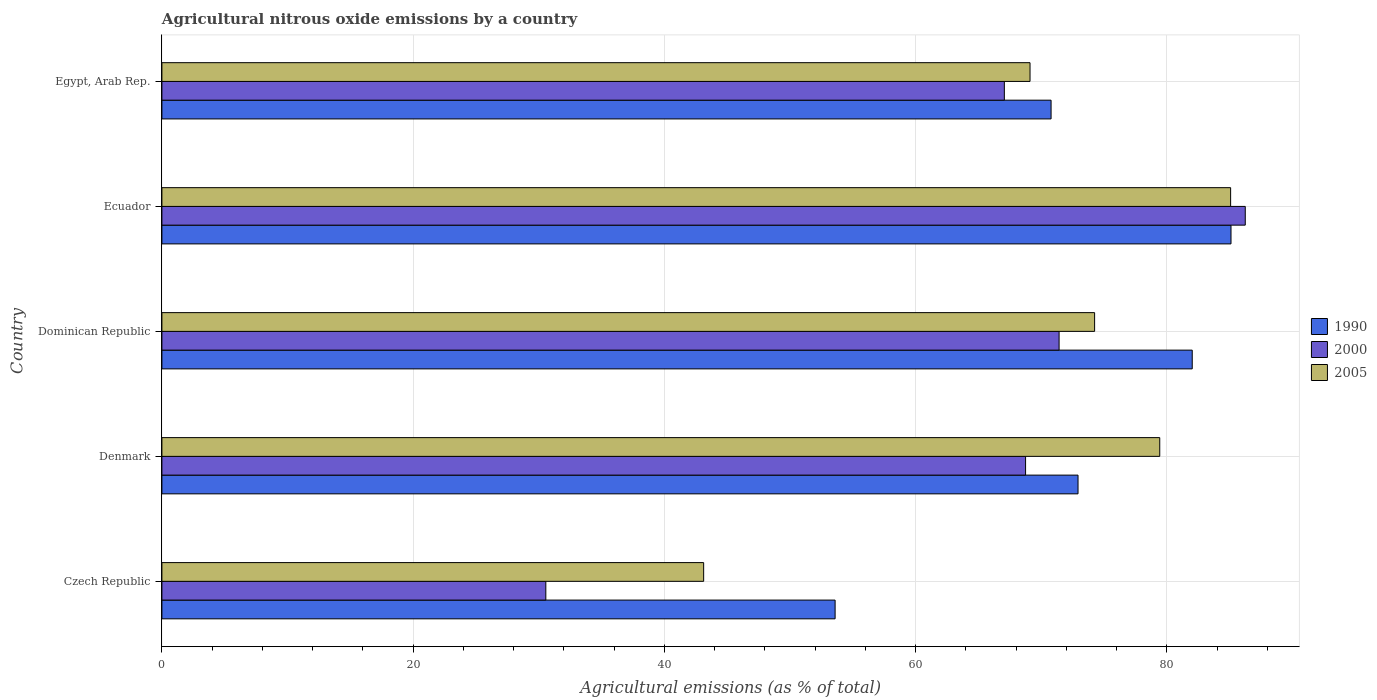How many groups of bars are there?
Keep it short and to the point. 5. Are the number of bars per tick equal to the number of legend labels?
Your answer should be compact. Yes. Are the number of bars on each tick of the Y-axis equal?
Offer a very short reply. Yes. What is the label of the 2nd group of bars from the top?
Provide a short and direct response. Ecuador. In how many cases, is the number of bars for a given country not equal to the number of legend labels?
Keep it short and to the point. 0. What is the amount of agricultural nitrous oxide emitted in 2005 in Czech Republic?
Your answer should be very brief. 43.13. Across all countries, what is the maximum amount of agricultural nitrous oxide emitted in 2005?
Provide a short and direct response. 85.08. Across all countries, what is the minimum amount of agricultural nitrous oxide emitted in 2005?
Offer a very short reply. 43.13. In which country was the amount of agricultural nitrous oxide emitted in 2005 maximum?
Provide a short and direct response. Ecuador. In which country was the amount of agricultural nitrous oxide emitted in 1990 minimum?
Keep it short and to the point. Czech Republic. What is the total amount of agricultural nitrous oxide emitted in 2005 in the graph?
Give a very brief answer. 351.02. What is the difference between the amount of agricultural nitrous oxide emitted in 1990 in Dominican Republic and that in Egypt, Arab Rep.?
Ensure brevity in your answer.  11.24. What is the difference between the amount of agricultural nitrous oxide emitted in 2000 in Czech Republic and the amount of agricultural nitrous oxide emitted in 2005 in Egypt, Arab Rep.?
Provide a succinct answer. -38.55. What is the average amount of agricultural nitrous oxide emitted in 2005 per country?
Provide a succinct answer. 70.2. What is the difference between the amount of agricultural nitrous oxide emitted in 1990 and amount of agricultural nitrous oxide emitted in 2000 in Czech Republic?
Your response must be concise. 23.03. What is the ratio of the amount of agricultural nitrous oxide emitted in 1990 in Denmark to that in Egypt, Arab Rep.?
Your answer should be very brief. 1.03. What is the difference between the highest and the second highest amount of agricultural nitrous oxide emitted in 2000?
Your answer should be very brief. 14.82. What is the difference between the highest and the lowest amount of agricultural nitrous oxide emitted in 1990?
Make the answer very short. 31.52. In how many countries, is the amount of agricultural nitrous oxide emitted in 1990 greater than the average amount of agricultural nitrous oxide emitted in 1990 taken over all countries?
Provide a succinct answer. 3. Is the sum of the amount of agricultural nitrous oxide emitted in 1990 in Czech Republic and Ecuador greater than the maximum amount of agricultural nitrous oxide emitted in 2005 across all countries?
Keep it short and to the point. Yes. What does the 2nd bar from the bottom in Denmark represents?
Your answer should be very brief. 2000. What is the difference between two consecutive major ticks on the X-axis?
Keep it short and to the point. 20. Does the graph contain grids?
Offer a very short reply. Yes. Where does the legend appear in the graph?
Offer a terse response. Center right. What is the title of the graph?
Your response must be concise. Agricultural nitrous oxide emissions by a country. What is the label or title of the X-axis?
Offer a terse response. Agricultural emissions (as % of total). What is the Agricultural emissions (as % of total) in 1990 in Czech Republic?
Make the answer very short. 53.6. What is the Agricultural emissions (as % of total) of 2000 in Czech Republic?
Provide a short and direct response. 30.56. What is the Agricultural emissions (as % of total) of 2005 in Czech Republic?
Your answer should be compact. 43.13. What is the Agricultural emissions (as % of total) of 1990 in Denmark?
Offer a terse response. 72.93. What is the Agricultural emissions (as % of total) of 2000 in Denmark?
Make the answer very short. 68.76. What is the Agricultural emissions (as % of total) of 2005 in Denmark?
Offer a very short reply. 79.44. What is the Agricultural emissions (as % of total) in 1990 in Dominican Republic?
Offer a terse response. 82.03. What is the Agricultural emissions (as % of total) of 2000 in Dominican Republic?
Offer a terse response. 71.43. What is the Agricultural emissions (as % of total) in 2005 in Dominican Republic?
Give a very brief answer. 74.25. What is the Agricultural emissions (as % of total) of 1990 in Ecuador?
Offer a very short reply. 85.11. What is the Agricultural emissions (as % of total) of 2000 in Ecuador?
Keep it short and to the point. 86.25. What is the Agricultural emissions (as % of total) in 2005 in Ecuador?
Make the answer very short. 85.08. What is the Agricultural emissions (as % of total) in 1990 in Egypt, Arab Rep.?
Your answer should be compact. 70.79. What is the Agricultural emissions (as % of total) in 2000 in Egypt, Arab Rep.?
Offer a very short reply. 67.07. What is the Agricultural emissions (as % of total) in 2005 in Egypt, Arab Rep.?
Give a very brief answer. 69.11. Across all countries, what is the maximum Agricultural emissions (as % of total) in 1990?
Ensure brevity in your answer.  85.11. Across all countries, what is the maximum Agricultural emissions (as % of total) in 2000?
Provide a short and direct response. 86.25. Across all countries, what is the maximum Agricultural emissions (as % of total) in 2005?
Offer a terse response. 85.08. Across all countries, what is the minimum Agricultural emissions (as % of total) of 1990?
Give a very brief answer. 53.6. Across all countries, what is the minimum Agricultural emissions (as % of total) in 2000?
Give a very brief answer. 30.56. Across all countries, what is the minimum Agricultural emissions (as % of total) in 2005?
Your answer should be very brief. 43.13. What is the total Agricultural emissions (as % of total) of 1990 in the graph?
Your answer should be compact. 364.46. What is the total Agricultural emissions (as % of total) in 2000 in the graph?
Your answer should be compact. 324.07. What is the total Agricultural emissions (as % of total) of 2005 in the graph?
Your response must be concise. 351.02. What is the difference between the Agricultural emissions (as % of total) of 1990 in Czech Republic and that in Denmark?
Your response must be concise. -19.34. What is the difference between the Agricultural emissions (as % of total) in 2000 in Czech Republic and that in Denmark?
Offer a very short reply. -38.19. What is the difference between the Agricultural emissions (as % of total) of 2005 in Czech Republic and that in Denmark?
Offer a very short reply. -36.31. What is the difference between the Agricultural emissions (as % of total) in 1990 in Czech Republic and that in Dominican Republic?
Your answer should be compact. -28.43. What is the difference between the Agricultural emissions (as % of total) of 2000 in Czech Republic and that in Dominican Republic?
Offer a terse response. -40.86. What is the difference between the Agricultural emissions (as % of total) of 2005 in Czech Republic and that in Dominican Republic?
Keep it short and to the point. -31.12. What is the difference between the Agricultural emissions (as % of total) of 1990 in Czech Republic and that in Ecuador?
Provide a short and direct response. -31.52. What is the difference between the Agricultural emissions (as % of total) of 2000 in Czech Republic and that in Ecuador?
Ensure brevity in your answer.  -55.68. What is the difference between the Agricultural emissions (as % of total) of 2005 in Czech Republic and that in Ecuador?
Provide a short and direct response. -41.95. What is the difference between the Agricultural emissions (as % of total) in 1990 in Czech Republic and that in Egypt, Arab Rep.?
Give a very brief answer. -17.19. What is the difference between the Agricultural emissions (as % of total) of 2000 in Czech Republic and that in Egypt, Arab Rep.?
Your answer should be compact. -36.5. What is the difference between the Agricultural emissions (as % of total) of 2005 in Czech Republic and that in Egypt, Arab Rep.?
Keep it short and to the point. -25.98. What is the difference between the Agricultural emissions (as % of total) in 1990 in Denmark and that in Dominican Republic?
Make the answer very short. -9.09. What is the difference between the Agricultural emissions (as % of total) in 2000 in Denmark and that in Dominican Republic?
Your response must be concise. -2.67. What is the difference between the Agricultural emissions (as % of total) in 2005 in Denmark and that in Dominican Republic?
Your response must be concise. 5.19. What is the difference between the Agricultural emissions (as % of total) of 1990 in Denmark and that in Ecuador?
Provide a succinct answer. -12.18. What is the difference between the Agricultural emissions (as % of total) of 2000 in Denmark and that in Ecuador?
Give a very brief answer. -17.49. What is the difference between the Agricultural emissions (as % of total) of 2005 in Denmark and that in Ecuador?
Your response must be concise. -5.64. What is the difference between the Agricultural emissions (as % of total) of 1990 in Denmark and that in Egypt, Arab Rep.?
Your response must be concise. 2.15. What is the difference between the Agricultural emissions (as % of total) in 2000 in Denmark and that in Egypt, Arab Rep.?
Provide a short and direct response. 1.69. What is the difference between the Agricultural emissions (as % of total) in 2005 in Denmark and that in Egypt, Arab Rep.?
Your response must be concise. 10.33. What is the difference between the Agricultural emissions (as % of total) of 1990 in Dominican Republic and that in Ecuador?
Your response must be concise. -3.09. What is the difference between the Agricultural emissions (as % of total) in 2000 in Dominican Republic and that in Ecuador?
Keep it short and to the point. -14.82. What is the difference between the Agricultural emissions (as % of total) of 2005 in Dominican Republic and that in Ecuador?
Provide a short and direct response. -10.83. What is the difference between the Agricultural emissions (as % of total) of 1990 in Dominican Republic and that in Egypt, Arab Rep.?
Your answer should be compact. 11.24. What is the difference between the Agricultural emissions (as % of total) in 2000 in Dominican Republic and that in Egypt, Arab Rep.?
Ensure brevity in your answer.  4.36. What is the difference between the Agricultural emissions (as % of total) of 2005 in Dominican Republic and that in Egypt, Arab Rep.?
Your answer should be compact. 5.14. What is the difference between the Agricultural emissions (as % of total) of 1990 in Ecuador and that in Egypt, Arab Rep.?
Provide a succinct answer. 14.32. What is the difference between the Agricultural emissions (as % of total) of 2000 in Ecuador and that in Egypt, Arab Rep.?
Provide a short and direct response. 19.18. What is the difference between the Agricultural emissions (as % of total) of 2005 in Ecuador and that in Egypt, Arab Rep.?
Provide a succinct answer. 15.97. What is the difference between the Agricultural emissions (as % of total) in 1990 in Czech Republic and the Agricultural emissions (as % of total) in 2000 in Denmark?
Offer a terse response. -15.16. What is the difference between the Agricultural emissions (as % of total) in 1990 in Czech Republic and the Agricultural emissions (as % of total) in 2005 in Denmark?
Your answer should be compact. -25.85. What is the difference between the Agricultural emissions (as % of total) of 2000 in Czech Republic and the Agricultural emissions (as % of total) of 2005 in Denmark?
Give a very brief answer. -48.88. What is the difference between the Agricultural emissions (as % of total) in 1990 in Czech Republic and the Agricultural emissions (as % of total) in 2000 in Dominican Republic?
Your answer should be compact. -17.83. What is the difference between the Agricultural emissions (as % of total) in 1990 in Czech Republic and the Agricultural emissions (as % of total) in 2005 in Dominican Republic?
Provide a short and direct response. -20.66. What is the difference between the Agricultural emissions (as % of total) in 2000 in Czech Republic and the Agricultural emissions (as % of total) in 2005 in Dominican Republic?
Provide a succinct answer. -43.69. What is the difference between the Agricultural emissions (as % of total) of 1990 in Czech Republic and the Agricultural emissions (as % of total) of 2000 in Ecuador?
Provide a short and direct response. -32.65. What is the difference between the Agricultural emissions (as % of total) of 1990 in Czech Republic and the Agricultural emissions (as % of total) of 2005 in Ecuador?
Your response must be concise. -31.49. What is the difference between the Agricultural emissions (as % of total) of 2000 in Czech Republic and the Agricultural emissions (as % of total) of 2005 in Ecuador?
Provide a succinct answer. -54.52. What is the difference between the Agricultural emissions (as % of total) of 1990 in Czech Republic and the Agricultural emissions (as % of total) of 2000 in Egypt, Arab Rep.?
Your answer should be compact. -13.47. What is the difference between the Agricultural emissions (as % of total) in 1990 in Czech Republic and the Agricultural emissions (as % of total) in 2005 in Egypt, Arab Rep.?
Keep it short and to the point. -15.52. What is the difference between the Agricultural emissions (as % of total) in 2000 in Czech Republic and the Agricultural emissions (as % of total) in 2005 in Egypt, Arab Rep.?
Keep it short and to the point. -38.55. What is the difference between the Agricultural emissions (as % of total) of 1990 in Denmark and the Agricultural emissions (as % of total) of 2000 in Dominican Republic?
Provide a short and direct response. 1.51. What is the difference between the Agricultural emissions (as % of total) in 1990 in Denmark and the Agricultural emissions (as % of total) in 2005 in Dominican Republic?
Provide a short and direct response. -1.32. What is the difference between the Agricultural emissions (as % of total) of 2000 in Denmark and the Agricultural emissions (as % of total) of 2005 in Dominican Republic?
Provide a succinct answer. -5.5. What is the difference between the Agricultural emissions (as % of total) of 1990 in Denmark and the Agricultural emissions (as % of total) of 2000 in Ecuador?
Offer a terse response. -13.31. What is the difference between the Agricultural emissions (as % of total) in 1990 in Denmark and the Agricultural emissions (as % of total) in 2005 in Ecuador?
Provide a short and direct response. -12.15. What is the difference between the Agricultural emissions (as % of total) in 2000 in Denmark and the Agricultural emissions (as % of total) in 2005 in Ecuador?
Give a very brief answer. -16.32. What is the difference between the Agricultural emissions (as % of total) in 1990 in Denmark and the Agricultural emissions (as % of total) in 2000 in Egypt, Arab Rep.?
Provide a short and direct response. 5.87. What is the difference between the Agricultural emissions (as % of total) in 1990 in Denmark and the Agricultural emissions (as % of total) in 2005 in Egypt, Arab Rep.?
Keep it short and to the point. 3.82. What is the difference between the Agricultural emissions (as % of total) of 2000 in Denmark and the Agricultural emissions (as % of total) of 2005 in Egypt, Arab Rep.?
Offer a terse response. -0.35. What is the difference between the Agricultural emissions (as % of total) in 1990 in Dominican Republic and the Agricultural emissions (as % of total) in 2000 in Ecuador?
Your answer should be very brief. -4.22. What is the difference between the Agricultural emissions (as % of total) in 1990 in Dominican Republic and the Agricultural emissions (as % of total) in 2005 in Ecuador?
Ensure brevity in your answer.  -3.06. What is the difference between the Agricultural emissions (as % of total) of 2000 in Dominican Republic and the Agricultural emissions (as % of total) of 2005 in Ecuador?
Offer a terse response. -13.66. What is the difference between the Agricultural emissions (as % of total) of 1990 in Dominican Republic and the Agricultural emissions (as % of total) of 2000 in Egypt, Arab Rep.?
Your answer should be compact. 14.96. What is the difference between the Agricultural emissions (as % of total) in 1990 in Dominican Republic and the Agricultural emissions (as % of total) in 2005 in Egypt, Arab Rep.?
Your answer should be compact. 12.91. What is the difference between the Agricultural emissions (as % of total) of 2000 in Dominican Republic and the Agricultural emissions (as % of total) of 2005 in Egypt, Arab Rep.?
Your answer should be compact. 2.31. What is the difference between the Agricultural emissions (as % of total) of 1990 in Ecuador and the Agricultural emissions (as % of total) of 2000 in Egypt, Arab Rep.?
Your answer should be very brief. 18.05. What is the difference between the Agricultural emissions (as % of total) in 1990 in Ecuador and the Agricultural emissions (as % of total) in 2005 in Egypt, Arab Rep.?
Provide a short and direct response. 16. What is the difference between the Agricultural emissions (as % of total) of 2000 in Ecuador and the Agricultural emissions (as % of total) of 2005 in Egypt, Arab Rep.?
Ensure brevity in your answer.  17.13. What is the average Agricultural emissions (as % of total) in 1990 per country?
Offer a terse response. 72.89. What is the average Agricultural emissions (as % of total) in 2000 per country?
Provide a succinct answer. 64.81. What is the average Agricultural emissions (as % of total) in 2005 per country?
Your answer should be compact. 70.2. What is the difference between the Agricultural emissions (as % of total) of 1990 and Agricultural emissions (as % of total) of 2000 in Czech Republic?
Your answer should be compact. 23.03. What is the difference between the Agricultural emissions (as % of total) of 1990 and Agricultural emissions (as % of total) of 2005 in Czech Republic?
Offer a very short reply. 10.47. What is the difference between the Agricultural emissions (as % of total) in 2000 and Agricultural emissions (as % of total) in 2005 in Czech Republic?
Your response must be concise. -12.57. What is the difference between the Agricultural emissions (as % of total) of 1990 and Agricultural emissions (as % of total) of 2000 in Denmark?
Give a very brief answer. 4.18. What is the difference between the Agricultural emissions (as % of total) in 1990 and Agricultural emissions (as % of total) in 2005 in Denmark?
Keep it short and to the point. -6.51. What is the difference between the Agricultural emissions (as % of total) in 2000 and Agricultural emissions (as % of total) in 2005 in Denmark?
Your answer should be very brief. -10.68. What is the difference between the Agricultural emissions (as % of total) in 1990 and Agricultural emissions (as % of total) in 2000 in Dominican Republic?
Offer a terse response. 10.6. What is the difference between the Agricultural emissions (as % of total) in 1990 and Agricultural emissions (as % of total) in 2005 in Dominican Republic?
Provide a succinct answer. 7.77. What is the difference between the Agricultural emissions (as % of total) of 2000 and Agricultural emissions (as % of total) of 2005 in Dominican Republic?
Keep it short and to the point. -2.83. What is the difference between the Agricultural emissions (as % of total) in 1990 and Agricultural emissions (as % of total) in 2000 in Ecuador?
Ensure brevity in your answer.  -1.14. What is the difference between the Agricultural emissions (as % of total) of 1990 and Agricultural emissions (as % of total) of 2005 in Ecuador?
Make the answer very short. 0.03. What is the difference between the Agricultural emissions (as % of total) of 2000 and Agricultural emissions (as % of total) of 2005 in Ecuador?
Offer a terse response. 1.16. What is the difference between the Agricultural emissions (as % of total) in 1990 and Agricultural emissions (as % of total) in 2000 in Egypt, Arab Rep.?
Keep it short and to the point. 3.72. What is the difference between the Agricultural emissions (as % of total) in 1990 and Agricultural emissions (as % of total) in 2005 in Egypt, Arab Rep.?
Keep it short and to the point. 1.68. What is the difference between the Agricultural emissions (as % of total) of 2000 and Agricultural emissions (as % of total) of 2005 in Egypt, Arab Rep.?
Offer a terse response. -2.05. What is the ratio of the Agricultural emissions (as % of total) of 1990 in Czech Republic to that in Denmark?
Your answer should be very brief. 0.73. What is the ratio of the Agricultural emissions (as % of total) of 2000 in Czech Republic to that in Denmark?
Give a very brief answer. 0.44. What is the ratio of the Agricultural emissions (as % of total) in 2005 in Czech Republic to that in Denmark?
Ensure brevity in your answer.  0.54. What is the ratio of the Agricultural emissions (as % of total) in 1990 in Czech Republic to that in Dominican Republic?
Offer a terse response. 0.65. What is the ratio of the Agricultural emissions (as % of total) of 2000 in Czech Republic to that in Dominican Republic?
Your answer should be compact. 0.43. What is the ratio of the Agricultural emissions (as % of total) in 2005 in Czech Republic to that in Dominican Republic?
Your answer should be compact. 0.58. What is the ratio of the Agricultural emissions (as % of total) in 1990 in Czech Republic to that in Ecuador?
Offer a terse response. 0.63. What is the ratio of the Agricultural emissions (as % of total) of 2000 in Czech Republic to that in Ecuador?
Give a very brief answer. 0.35. What is the ratio of the Agricultural emissions (as % of total) of 2005 in Czech Republic to that in Ecuador?
Provide a short and direct response. 0.51. What is the ratio of the Agricultural emissions (as % of total) of 1990 in Czech Republic to that in Egypt, Arab Rep.?
Offer a very short reply. 0.76. What is the ratio of the Agricultural emissions (as % of total) in 2000 in Czech Republic to that in Egypt, Arab Rep.?
Offer a terse response. 0.46. What is the ratio of the Agricultural emissions (as % of total) in 2005 in Czech Republic to that in Egypt, Arab Rep.?
Give a very brief answer. 0.62. What is the ratio of the Agricultural emissions (as % of total) in 1990 in Denmark to that in Dominican Republic?
Provide a succinct answer. 0.89. What is the ratio of the Agricultural emissions (as % of total) in 2000 in Denmark to that in Dominican Republic?
Provide a succinct answer. 0.96. What is the ratio of the Agricultural emissions (as % of total) in 2005 in Denmark to that in Dominican Republic?
Offer a terse response. 1.07. What is the ratio of the Agricultural emissions (as % of total) of 1990 in Denmark to that in Ecuador?
Your answer should be compact. 0.86. What is the ratio of the Agricultural emissions (as % of total) of 2000 in Denmark to that in Ecuador?
Your response must be concise. 0.8. What is the ratio of the Agricultural emissions (as % of total) of 2005 in Denmark to that in Ecuador?
Offer a terse response. 0.93. What is the ratio of the Agricultural emissions (as % of total) of 1990 in Denmark to that in Egypt, Arab Rep.?
Make the answer very short. 1.03. What is the ratio of the Agricultural emissions (as % of total) of 2000 in Denmark to that in Egypt, Arab Rep.?
Your response must be concise. 1.03. What is the ratio of the Agricultural emissions (as % of total) of 2005 in Denmark to that in Egypt, Arab Rep.?
Provide a succinct answer. 1.15. What is the ratio of the Agricultural emissions (as % of total) in 1990 in Dominican Republic to that in Ecuador?
Keep it short and to the point. 0.96. What is the ratio of the Agricultural emissions (as % of total) in 2000 in Dominican Republic to that in Ecuador?
Make the answer very short. 0.83. What is the ratio of the Agricultural emissions (as % of total) of 2005 in Dominican Republic to that in Ecuador?
Your response must be concise. 0.87. What is the ratio of the Agricultural emissions (as % of total) in 1990 in Dominican Republic to that in Egypt, Arab Rep.?
Keep it short and to the point. 1.16. What is the ratio of the Agricultural emissions (as % of total) of 2000 in Dominican Republic to that in Egypt, Arab Rep.?
Offer a very short reply. 1.06. What is the ratio of the Agricultural emissions (as % of total) in 2005 in Dominican Republic to that in Egypt, Arab Rep.?
Your response must be concise. 1.07. What is the ratio of the Agricultural emissions (as % of total) in 1990 in Ecuador to that in Egypt, Arab Rep.?
Keep it short and to the point. 1.2. What is the ratio of the Agricultural emissions (as % of total) in 2000 in Ecuador to that in Egypt, Arab Rep.?
Give a very brief answer. 1.29. What is the ratio of the Agricultural emissions (as % of total) of 2005 in Ecuador to that in Egypt, Arab Rep.?
Your answer should be very brief. 1.23. What is the difference between the highest and the second highest Agricultural emissions (as % of total) in 1990?
Your answer should be compact. 3.09. What is the difference between the highest and the second highest Agricultural emissions (as % of total) in 2000?
Your response must be concise. 14.82. What is the difference between the highest and the second highest Agricultural emissions (as % of total) of 2005?
Ensure brevity in your answer.  5.64. What is the difference between the highest and the lowest Agricultural emissions (as % of total) in 1990?
Provide a succinct answer. 31.52. What is the difference between the highest and the lowest Agricultural emissions (as % of total) of 2000?
Offer a very short reply. 55.68. What is the difference between the highest and the lowest Agricultural emissions (as % of total) in 2005?
Provide a succinct answer. 41.95. 